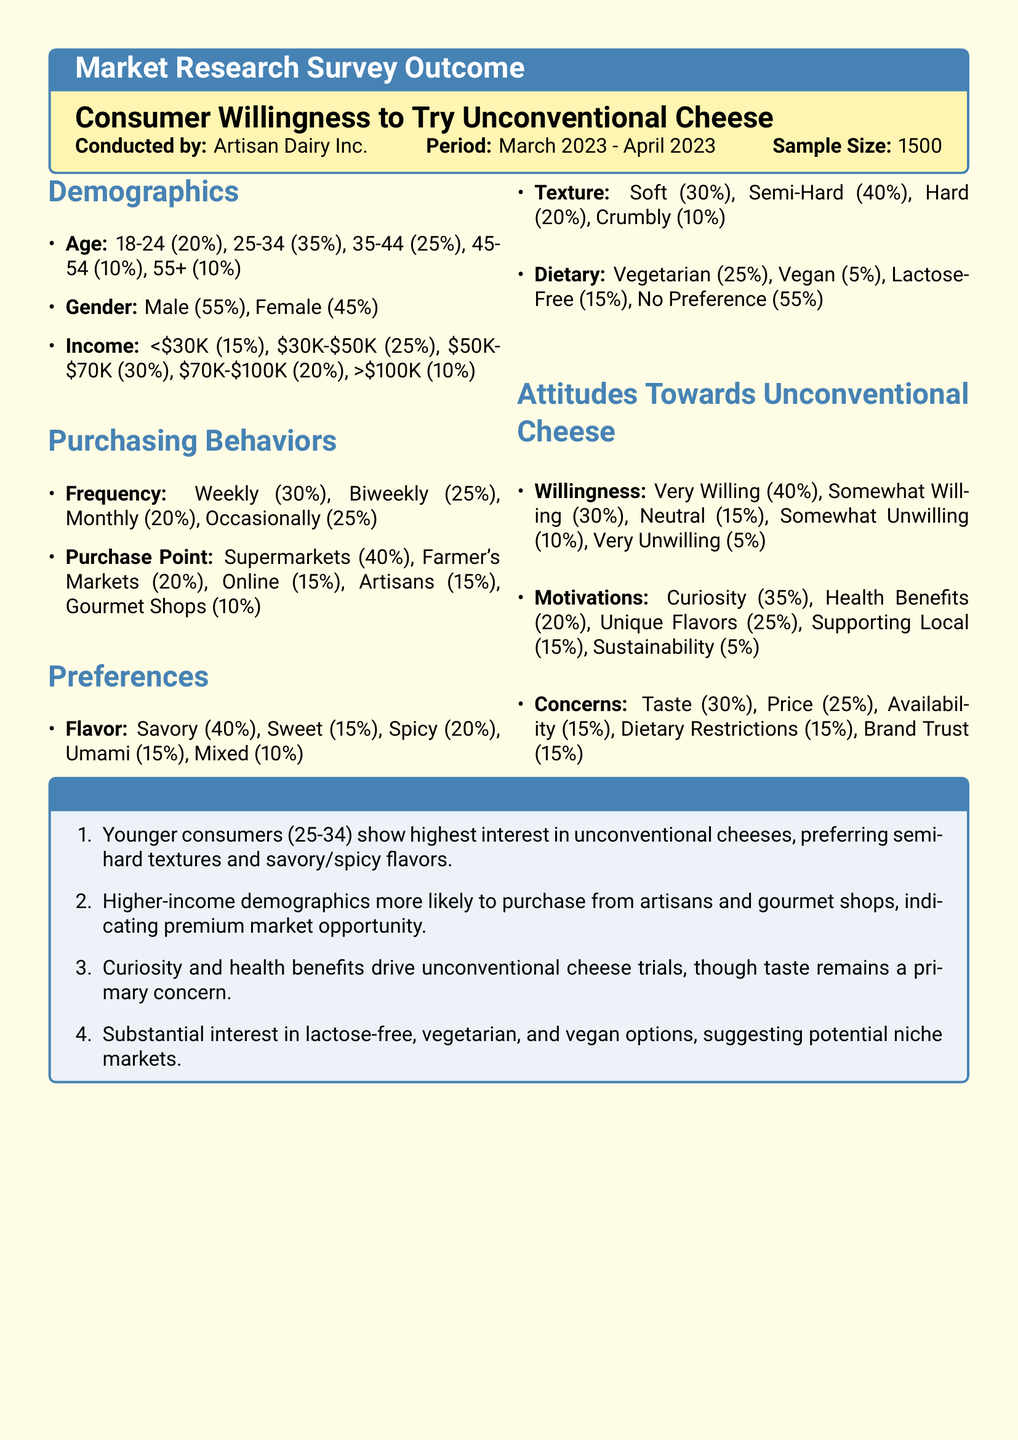what was the sample size of the survey? The sample size is mentioned in the header of the document as 1500 individuals who participated in the survey.
Answer: 1500 what age group has the highest percentage in the survey? The age group 25-34 has the highest percentage at 35%, indicating it is the most represented group in the survey.
Answer: 25-34 what percentage of respondents are very willing to try unconventional cheese? The document provides a specific statistic indicating that 40% of respondents are very willing to try unconventional cheese.
Answer: 40% which purchasing point has the highest percentage among respondents? The survey indicates that supermarkets are the primary purchasing point for 40% of respondents, making it the most common choice.
Answer: Supermarkets what are the top motivations for trying unconventional cheese? The survey highlights that curiosity (35%) and unique flavors (25%) are among the main motivations, showing higher interest in these factors.
Answer: Curiosity, Unique Flavors what is the percentage of consumers who prefer lactose-free cheese? According to the data, 15% of consumers expressed a preference for lactose-free options in their cheese choices.
Answer: 15% what texture is preferred by the majority of respondents? The majority of respondents (40%) prefer semi-hard textures in cheese, making it the most favored option.
Answer: Semi-Hard which demographic shows the highest interest in unconventional cheese? The younger demographic, particularly the 25-34 age group, demonstrates the highest interest in unconventional cheeses.
Answer: 25-34 what is consumers' primary concern regarding unconventional cheese? Taste is indicated as the primary concern for 30% of respondents when considering unconventional cheese.
Answer: Taste 